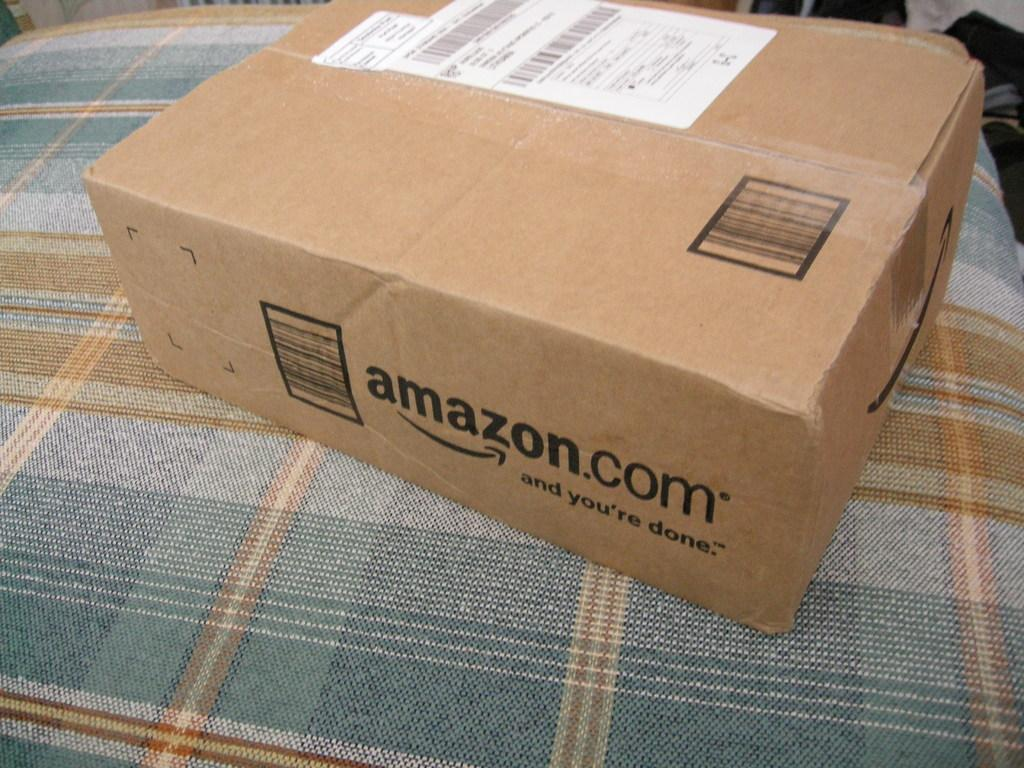Provide a one-sentence caption for the provided image. A brown box that says amazon.com on it. 